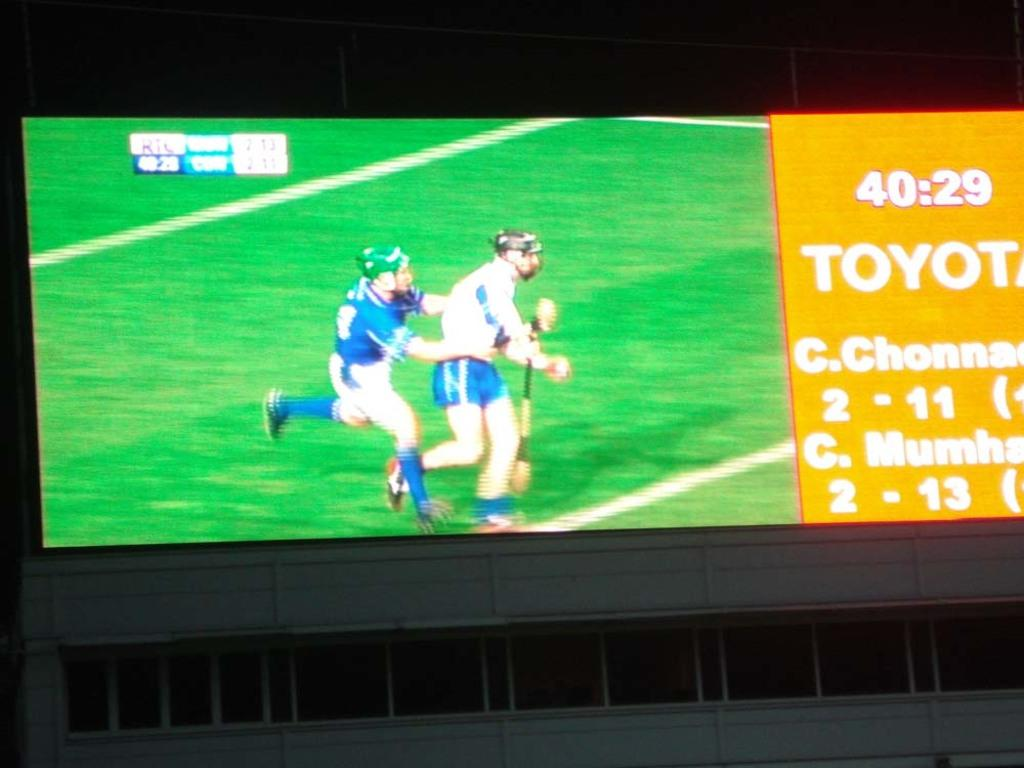<image>
Relay a brief, clear account of the picture shown. Toyota is sponsoring the play coverage in this sporting event. 